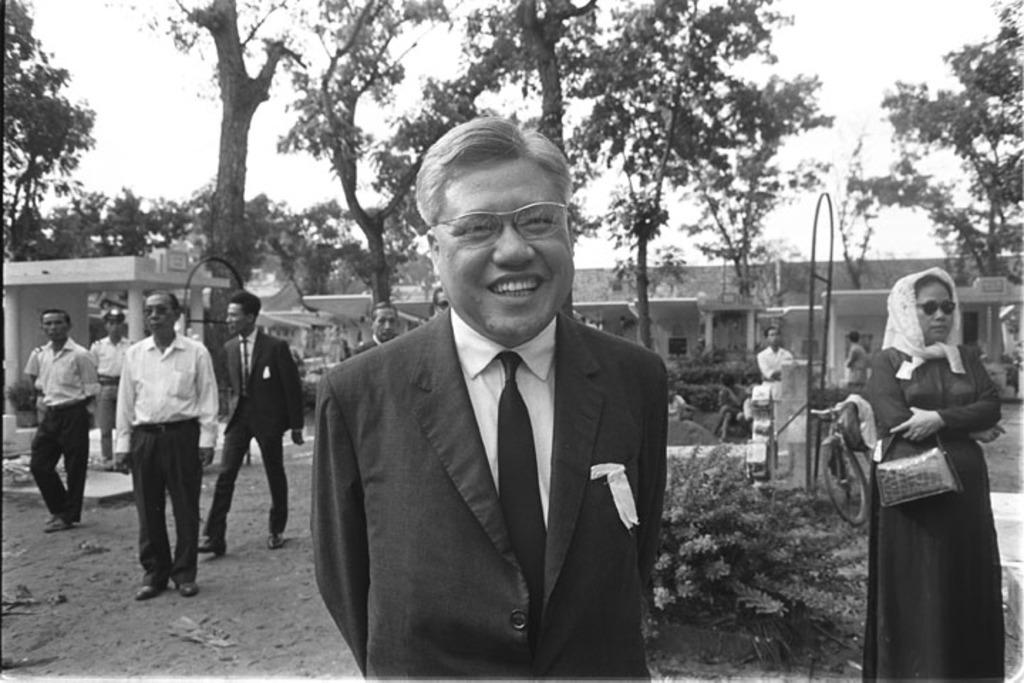What can be seen on the ground in the image? There are people on the ground in the image. What type of structures can be seen in the background of the image? There are houses visible in the background of the image. What type of vegetation is present in the background of the image? Trees and plants are present in the background of the image. Can you tell me how many toads are present in the image? There are no toads present in the image. What type of agreement was reached by the people in the image? There is no indication of an agreement or any interaction between the people in the image. 